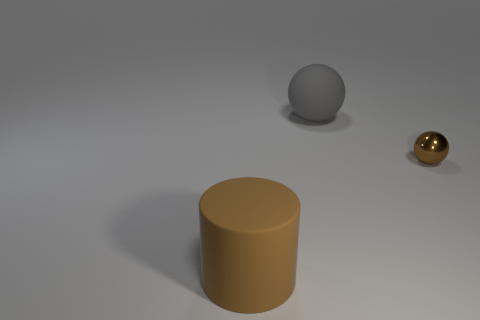Add 2 big yellow blocks. How many objects exist? 5 Subtract all spheres. How many objects are left? 1 Add 1 small shiny objects. How many small shiny objects are left? 2 Add 1 small gray matte cylinders. How many small gray matte cylinders exist? 1 Subtract 0 green spheres. How many objects are left? 3 Subtract all tiny brown metal objects. Subtract all rubber balls. How many objects are left? 1 